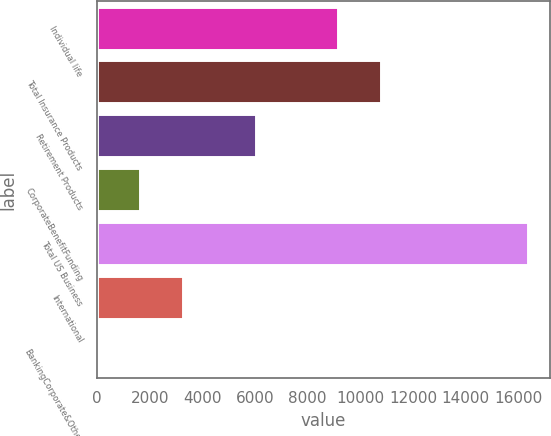<chart> <loc_0><loc_0><loc_500><loc_500><bar_chart><fcel>Individual life<fcel>Total Insurance Products<fcel>Retirement Products<fcel>CorporateBenefitFunding<fcel>Total US Business<fcel>International<fcel>BankingCorporate&Other<nl><fcel>9134<fcel>10771.8<fcel>6023<fcel>1641.8<fcel>16382<fcel>3279.6<fcel>4<nl></chart> 